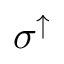<formula> <loc_0><loc_0><loc_500><loc_500>\sigma ^ { \uparrow }</formula> 